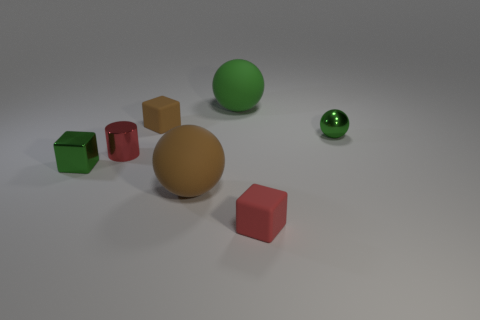Which objects in the image are spherical, and how do their sizes compare? In the image, there are two spherical objects. The larger one has a matte green finish and is notably bigger than the smaller, shiny green sphere. Are there any objects that have identical shapes but different colors? Yes, there are two cubes that have the same shape but different colors; one is green and the other is brown. 